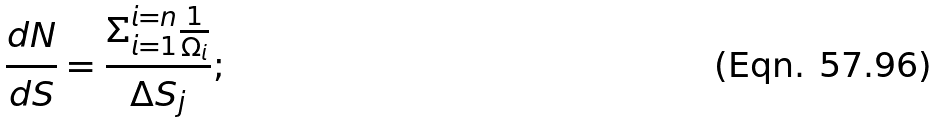Convert formula to latex. <formula><loc_0><loc_0><loc_500><loc_500>\frac { d N } { d S } = \frac { \Sigma ^ { i = n } _ { i = 1 } \frac { 1 } { \Omega _ { i } } } { \Delta S _ { j } } ;</formula> 